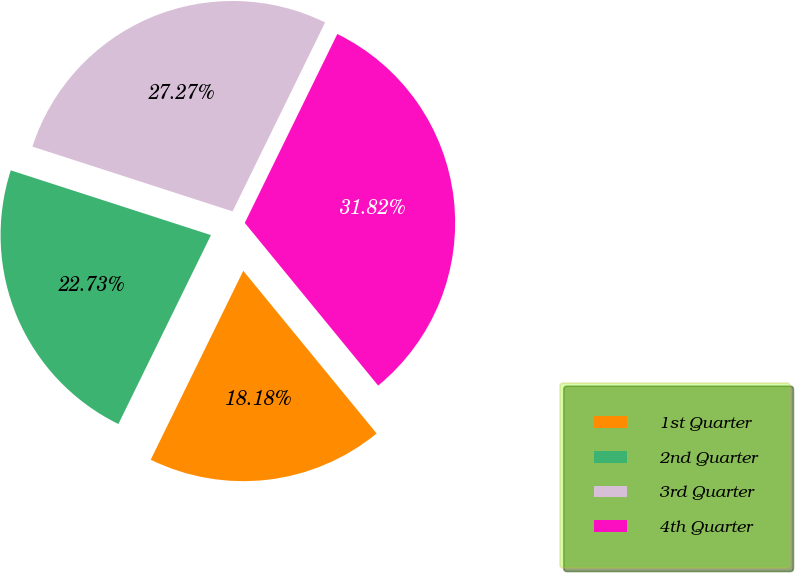Convert chart. <chart><loc_0><loc_0><loc_500><loc_500><pie_chart><fcel>1st Quarter<fcel>2nd Quarter<fcel>3rd Quarter<fcel>4th Quarter<nl><fcel>18.18%<fcel>22.73%<fcel>27.27%<fcel>31.82%<nl></chart> 